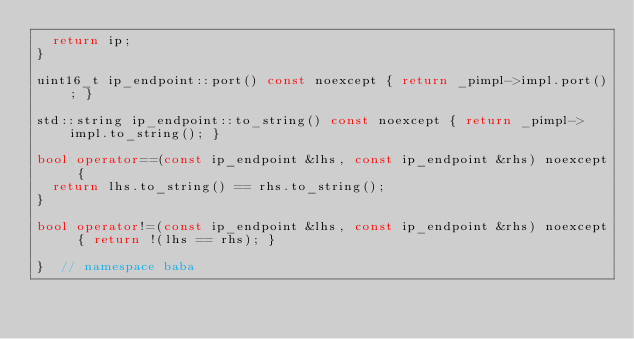Convert code to text. <code><loc_0><loc_0><loc_500><loc_500><_C++_>  return ip;
}

uint16_t ip_endpoint::port() const noexcept { return _pimpl->impl.port(); }

std::string ip_endpoint::to_string() const noexcept { return _pimpl->impl.to_string(); }

bool operator==(const ip_endpoint &lhs, const ip_endpoint &rhs) noexcept {
  return lhs.to_string() == rhs.to_string();
}

bool operator!=(const ip_endpoint &lhs, const ip_endpoint &rhs) noexcept { return !(lhs == rhs); }

}  // namespace baba</code> 